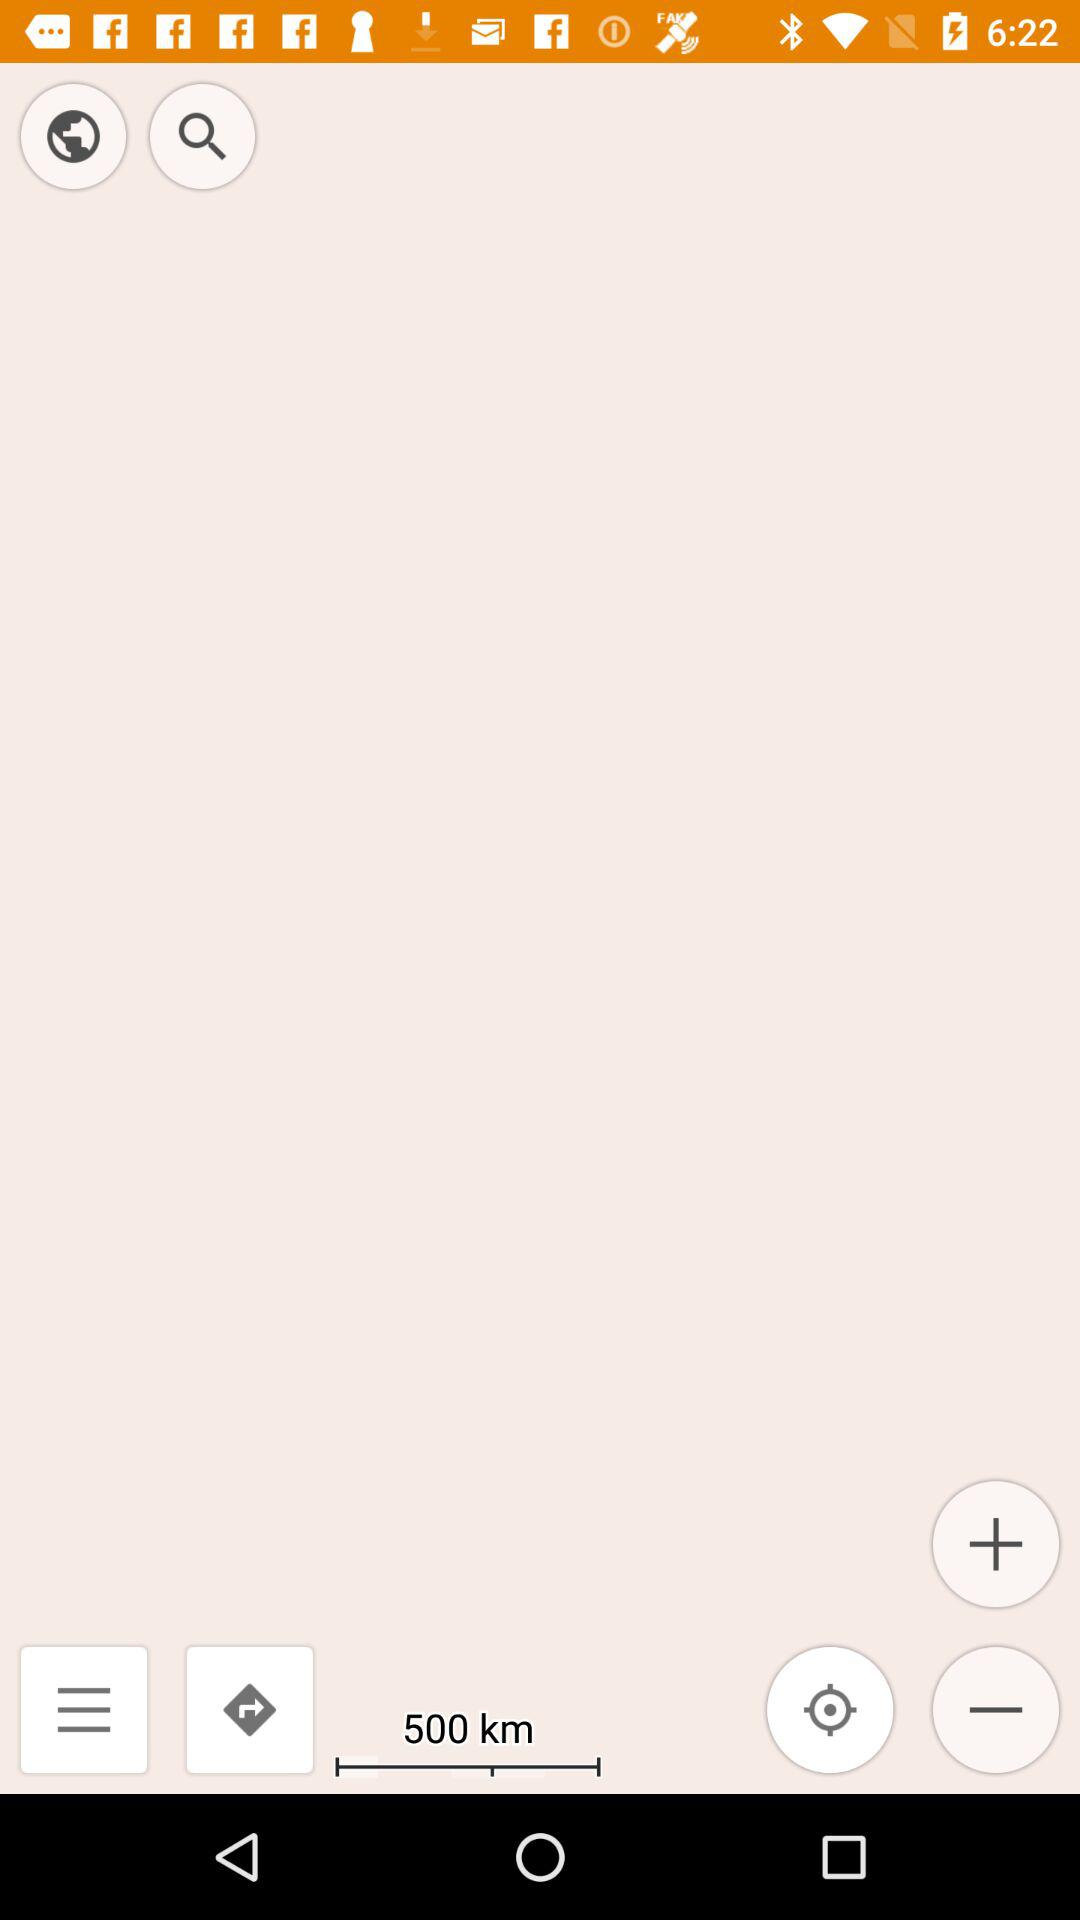How many kilometers away is the destination?
Answer the question using a single word or phrase. 500 